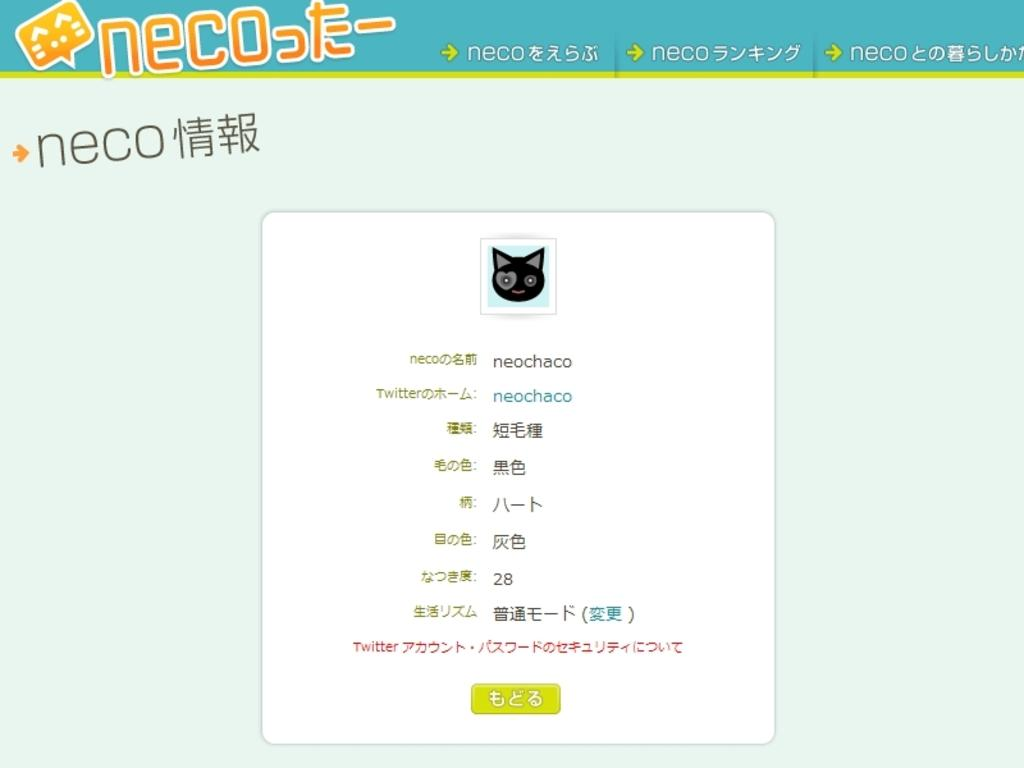What type of image is being described? The image is animated. What else can be found in the image besides the animation? There is text in the image. Where is the playground located in the image? There is no playground present in the image; it is an animated image with text. What type of air is visible in the image? There is no specific type of air visible in the image, as it is an animated image with text. 